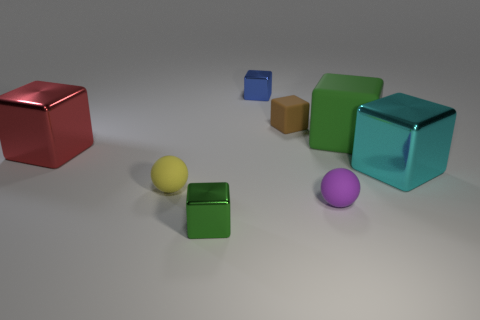Subtract all tiny green cubes. How many cubes are left? 5 Add 1 large matte objects. How many objects exist? 9 Subtract all red cubes. How many cubes are left? 5 Subtract all blue cubes. How many purple spheres are left? 1 Subtract all red metallic things. Subtract all small things. How many objects are left? 2 Add 6 red metal cubes. How many red metal cubes are left? 7 Add 1 small yellow matte balls. How many small yellow matte balls exist? 2 Subtract 1 red cubes. How many objects are left? 7 Subtract all balls. How many objects are left? 6 Subtract 1 cubes. How many cubes are left? 5 